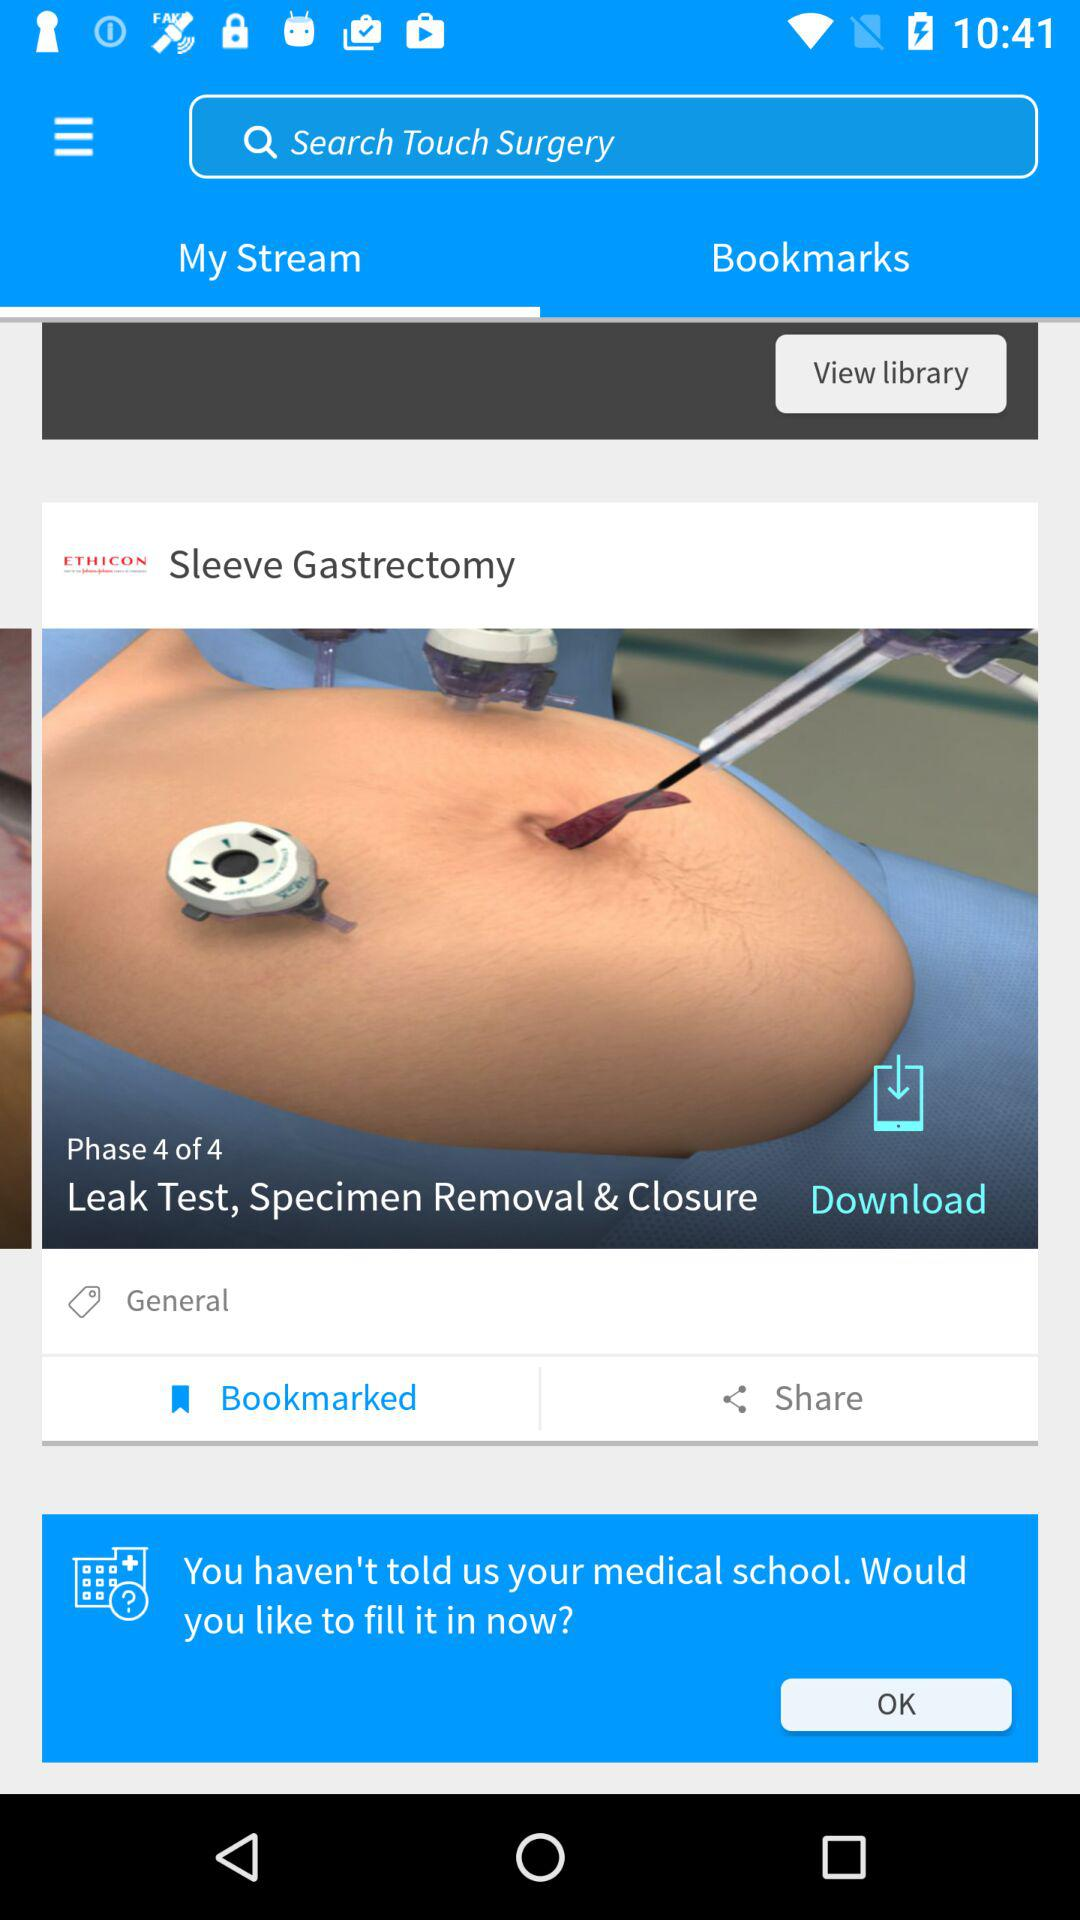How many tags are on the video?
Answer the question using a single word or phrase. 1 